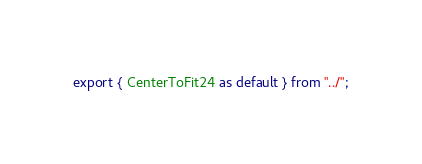<code> <loc_0><loc_0><loc_500><loc_500><_TypeScript_>export { CenterToFit24 as default } from "../";
</code> 